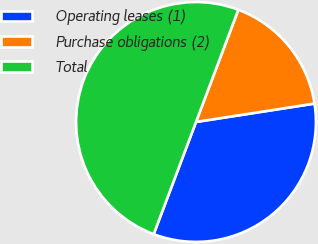<chart> <loc_0><loc_0><loc_500><loc_500><pie_chart><fcel>Operating leases (1)<fcel>Purchase obligations (2)<fcel>Total<nl><fcel>33.19%<fcel>16.81%<fcel>50.0%<nl></chart> 